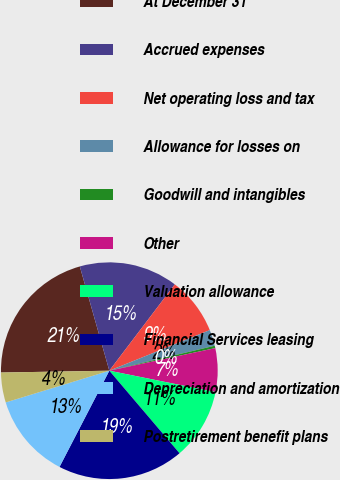<chart> <loc_0><loc_0><loc_500><loc_500><pie_chart><fcel>At December 31<fcel>Accrued expenses<fcel>Net operating loss and tax<fcel>Allowance for losses on<fcel>Goodwill and intangibles<fcel>Other<fcel>Valuation allowance<fcel>Financial Services leasing<fcel>Depreciation and amortization<fcel>Postretirement benefit plans<nl><fcel>20.88%<fcel>14.72%<fcel>8.56%<fcel>2.41%<fcel>0.36%<fcel>6.51%<fcel>10.62%<fcel>18.82%<fcel>12.67%<fcel>4.46%<nl></chart> 